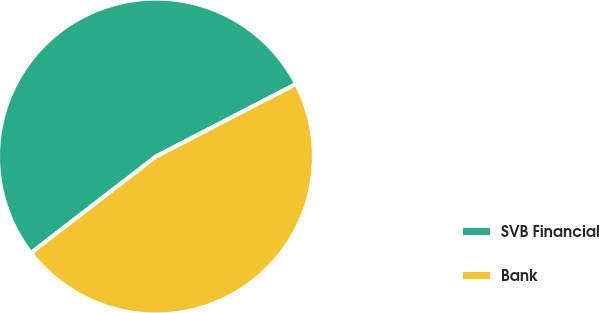Convert chart. <chart><loc_0><loc_0><loc_500><loc_500><pie_chart><fcel>SVB Financial<fcel>Bank<nl><fcel>52.85%<fcel>47.15%<nl></chart> 